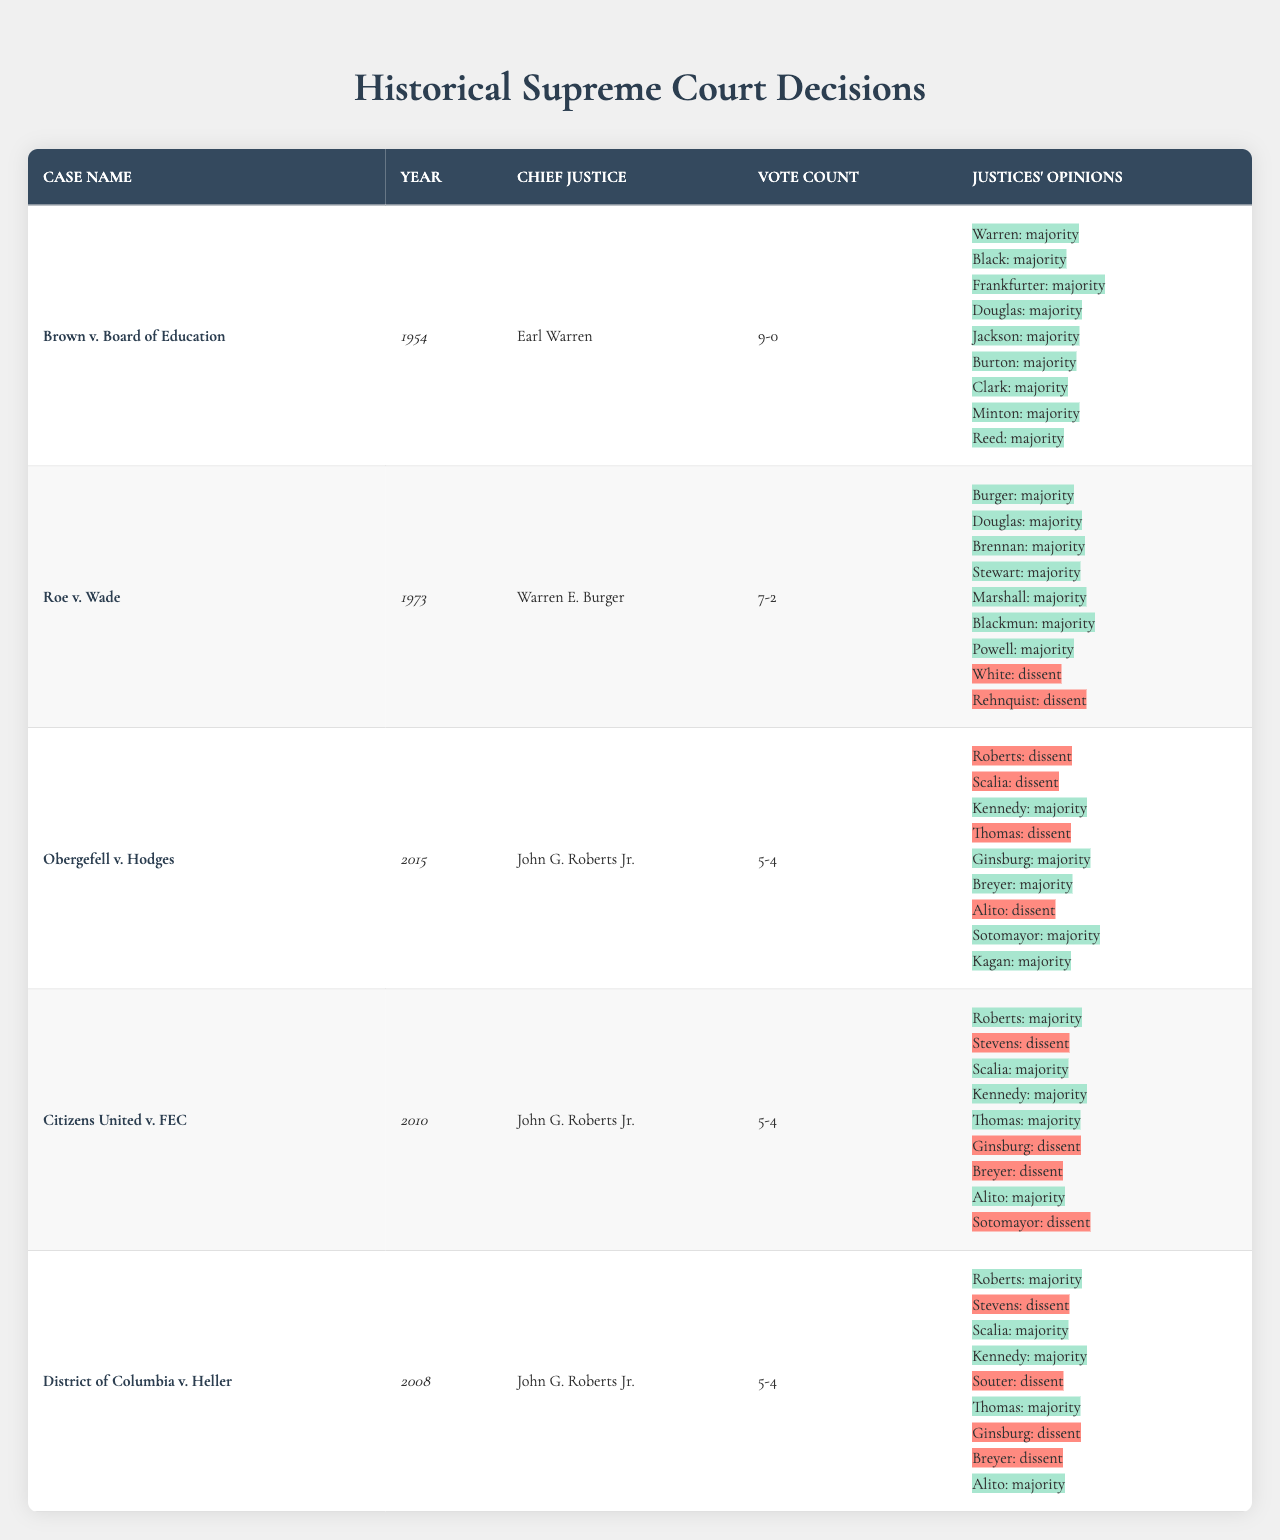What is the vote count for Brown v. Board of Education? The table explicitly states the vote count for this case. It shows that the vote count is "9-0."
Answer: 9-0 Who was the Chief Justice during Roe v. Wade? The table lists the Chief Justice for each case. For Roe v. Wade, it indicates "Warren E. Burger" as the Chief Justice.
Answer: Warren E. Burger In which year was Obergefell v. Hodges decided? The year for each case is mentioned in the table. Obergefell v. Hodges is marked as being decided in the year "2015."
Answer: 2015 How many justices voted in the majority for Citizens United v. FEC? The table identifies justices and their opinions. In the Citizens United v. FEC case, "5" justices are noted as voting in the majority.
Answer: 5 Did Chief Justice John G. Roberts Jr. vote in the majority for District of Columbia v. Heller? The table indicates the opinion of each justice. It shows that John G. Roberts Jr. voted in the majority for District of Columbia v. Heller.
Answer: Yes Which case had the narrowest vote margin? By examining the vote counts, both Obergefell v. Hodges and Citizens United v. FEC have a "5-4" vote margin, indicating they are the narrowest.
Answer: Obergefell v. Hodges, Citizens United v. FEC Was there a dissenting vote in Brown v. Board of Education? The table specifies the vote count for each case. It shows a "9-0" vote count for Brown v. Board of Education, meaning there were no dissenting votes.
Answer: No List the cases where Justice Ruth Bader Ginsburg was in the majority. By checking the table, Justice Ginsburg is reported in the majority for Roe v. Wade and Obergefell v. Hodges.
Answer: Roe v. Wade, Obergefell v. Hodges How many total justices dissented in Citizens United v. FEC? The table indicates that there are "4" dissenting votes in the Citizens United v. FEC case.
Answer: 4 What is the total number of cases represented in the table? The table lists a total of "5" distinct cases organized under individual entries.
Answer: 5 How many justices voted in favor of Roe v. Wade compared to dissenting votes? The table shows 7 justices voted in the majority and 2 dissented for Roe v. Wade, leading to a difference of 5 in favor of the majority.
Answer: 5 Were there any cases with a 9-0 vote count? The table indicates that Brown v. Board of Education is listed with a vote count of "9-0," confirming that there was indeed a case with this count.
Answer: Yes Identify the Chief Justice who presided over the most cases in this table. John G. Roberts Jr. presided over 3 cases (Obergefell v. Hodges, Citizens United v. FEC, and District of Columbia v. Heller), which is the highest count in the table.
Answer: John G. Roberts Jr 